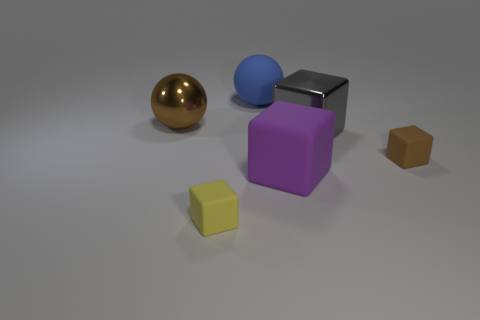Add 2 big brown shiny spheres. How many objects exist? 8 Subtract all spheres. How many objects are left? 4 Add 4 big gray metallic cylinders. How many big gray metallic cylinders exist? 4 Subtract 0 red cylinders. How many objects are left? 6 Subtract all small green blocks. Subtract all blue matte spheres. How many objects are left? 5 Add 6 big purple objects. How many big purple objects are left? 7 